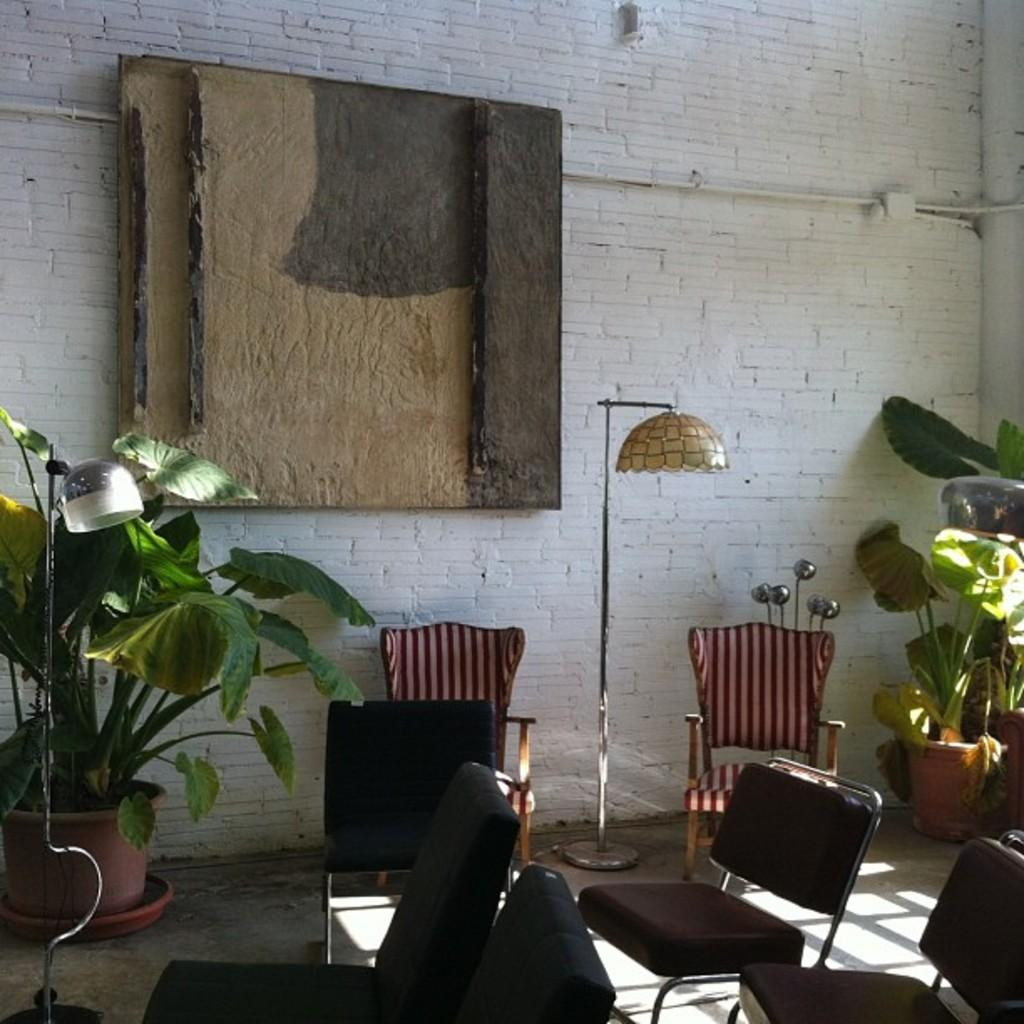What type of living organism can be seen in the image? There is a plant in the image. What type of furniture is present in the image? There are chairs in the image. What type of lighting is present in the image? There is a lamp in the image. What type of structure is visible in the image? There is a wall in the image. Can you hear someone coughing in the image? There is no sound present in the image, so it is not possible to determine if someone is coughing. Is there a lake visible in the image? There is no lake present in the image. 